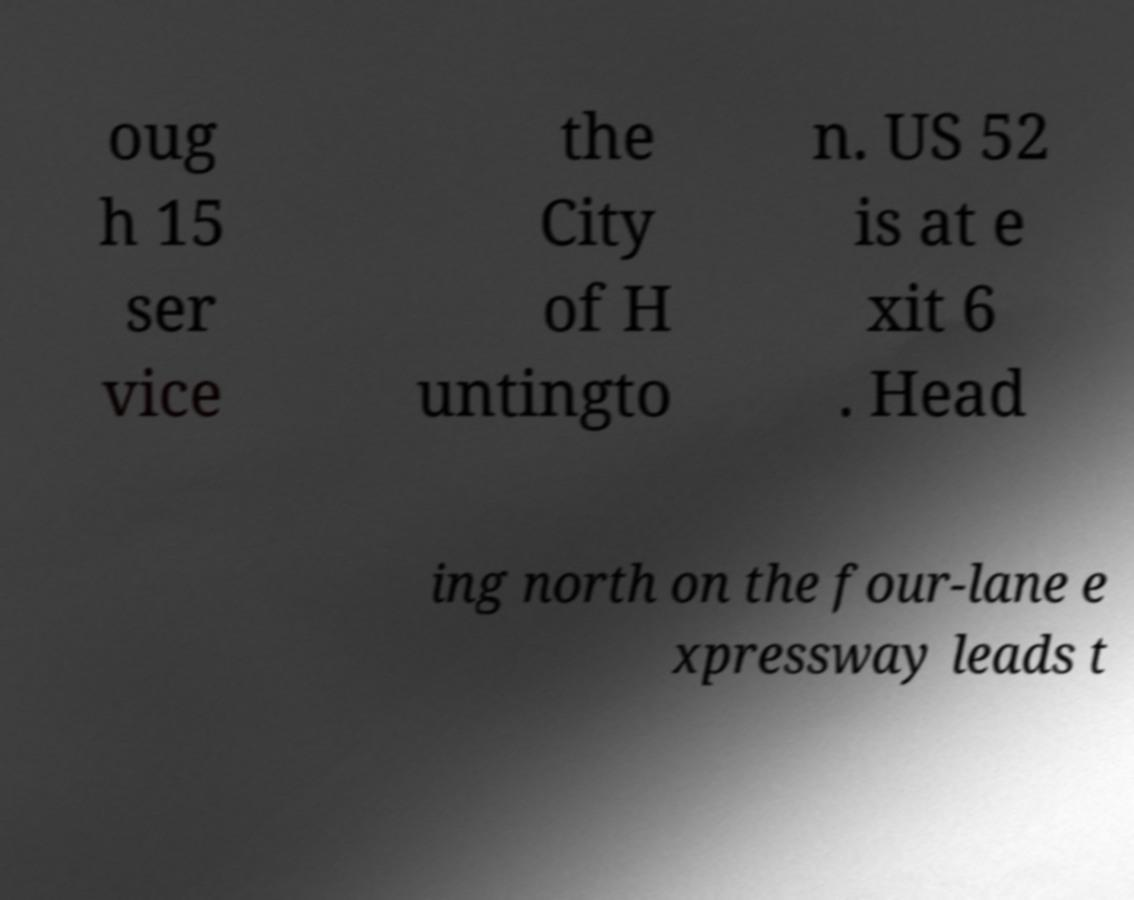Can you accurately transcribe the text from the provided image for me? oug h 15 ser vice the City of H untingto n. US 52 is at e xit 6 . Head ing north on the four-lane e xpressway leads t 